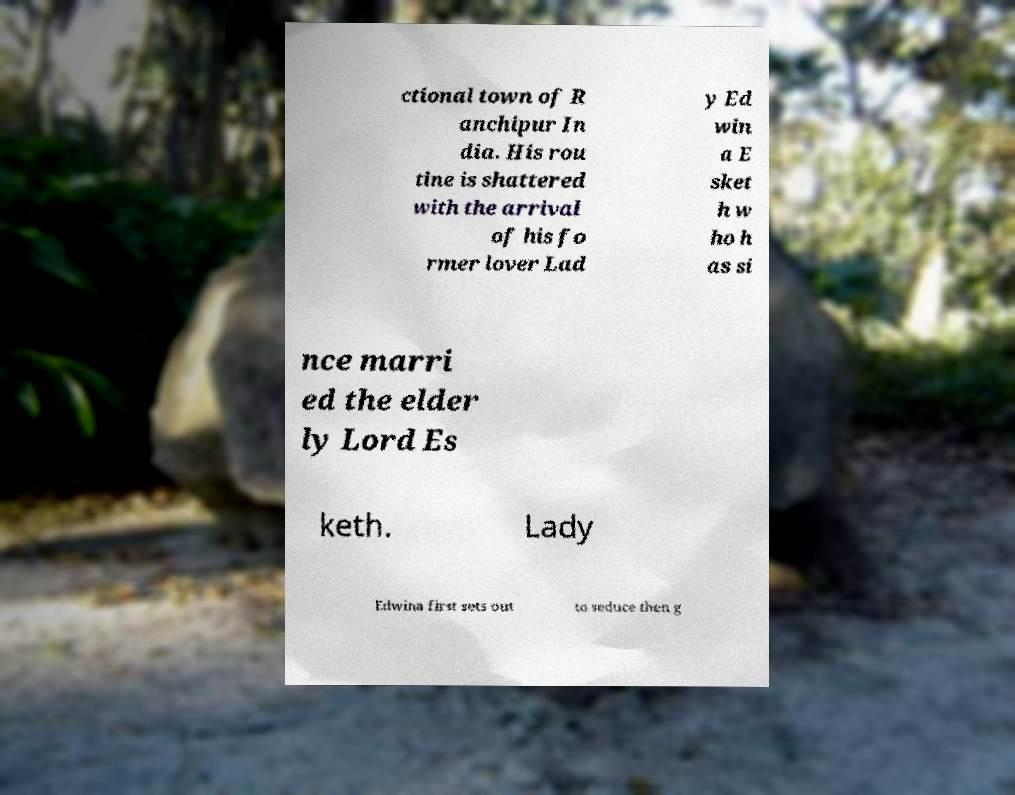What messages or text are displayed in this image? I need them in a readable, typed format. ctional town of R anchipur In dia. His rou tine is shattered with the arrival of his fo rmer lover Lad y Ed win a E sket h w ho h as si nce marri ed the elder ly Lord Es keth. Lady Edwina first sets out to seduce then g 